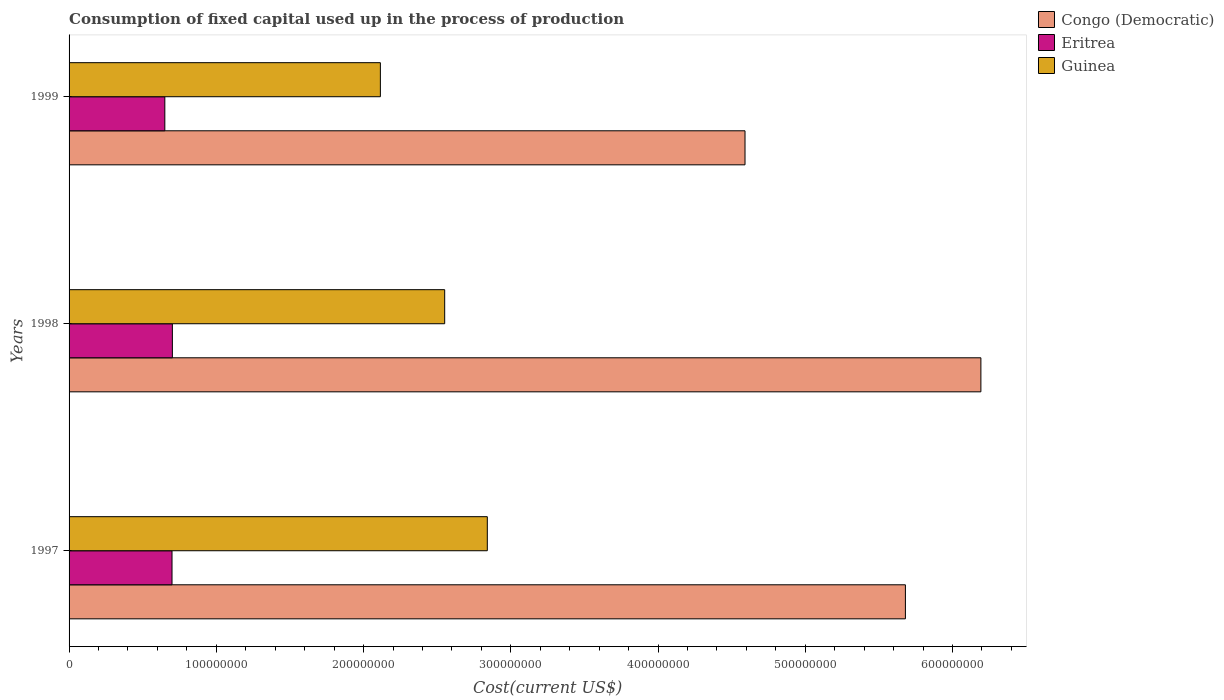How many different coloured bars are there?
Offer a terse response. 3. Are the number of bars on each tick of the Y-axis equal?
Give a very brief answer. Yes. How many bars are there on the 1st tick from the top?
Your answer should be compact. 3. What is the label of the 1st group of bars from the top?
Provide a short and direct response. 1999. In how many cases, is the number of bars for a given year not equal to the number of legend labels?
Your response must be concise. 0. What is the amount consumed in the process of production in Guinea in 1997?
Offer a terse response. 2.84e+08. Across all years, what is the maximum amount consumed in the process of production in Congo (Democratic)?
Offer a very short reply. 6.19e+08. Across all years, what is the minimum amount consumed in the process of production in Guinea?
Your answer should be compact. 2.11e+08. In which year was the amount consumed in the process of production in Guinea minimum?
Give a very brief answer. 1999. What is the total amount consumed in the process of production in Congo (Democratic) in the graph?
Ensure brevity in your answer.  1.65e+09. What is the difference between the amount consumed in the process of production in Guinea in 1998 and that in 1999?
Ensure brevity in your answer.  4.37e+07. What is the difference between the amount consumed in the process of production in Congo (Democratic) in 1997 and the amount consumed in the process of production in Guinea in 1998?
Keep it short and to the point. 3.13e+08. What is the average amount consumed in the process of production in Eritrea per year?
Make the answer very short. 6.84e+07. In the year 1999, what is the difference between the amount consumed in the process of production in Eritrea and amount consumed in the process of production in Guinea?
Offer a very short reply. -1.46e+08. In how many years, is the amount consumed in the process of production in Guinea greater than 360000000 US$?
Keep it short and to the point. 0. What is the ratio of the amount consumed in the process of production in Guinea in 1997 to that in 1998?
Your response must be concise. 1.11. Is the difference between the amount consumed in the process of production in Eritrea in 1997 and 1999 greater than the difference between the amount consumed in the process of production in Guinea in 1997 and 1999?
Keep it short and to the point. No. What is the difference between the highest and the second highest amount consumed in the process of production in Congo (Democratic)?
Offer a terse response. 5.13e+07. What is the difference between the highest and the lowest amount consumed in the process of production in Eritrea?
Your answer should be compact. 5.13e+06. In how many years, is the amount consumed in the process of production in Eritrea greater than the average amount consumed in the process of production in Eritrea taken over all years?
Give a very brief answer. 2. Is the sum of the amount consumed in the process of production in Eritrea in 1997 and 1999 greater than the maximum amount consumed in the process of production in Congo (Democratic) across all years?
Offer a very short reply. No. What does the 1st bar from the top in 1999 represents?
Provide a succinct answer. Guinea. What does the 1st bar from the bottom in 1999 represents?
Ensure brevity in your answer.  Congo (Democratic). Is it the case that in every year, the sum of the amount consumed in the process of production in Guinea and amount consumed in the process of production in Congo (Democratic) is greater than the amount consumed in the process of production in Eritrea?
Offer a terse response. Yes. Are all the bars in the graph horizontal?
Make the answer very short. Yes. How many years are there in the graph?
Your answer should be compact. 3. Does the graph contain grids?
Give a very brief answer. No. Where does the legend appear in the graph?
Ensure brevity in your answer.  Top right. How many legend labels are there?
Ensure brevity in your answer.  3. How are the legend labels stacked?
Make the answer very short. Vertical. What is the title of the graph?
Your answer should be compact. Consumption of fixed capital used up in the process of production. What is the label or title of the X-axis?
Give a very brief answer. Cost(current US$). What is the label or title of the Y-axis?
Provide a short and direct response. Years. What is the Cost(current US$) in Congo (Democratic) in 1997?
Provide a succinct answer. 5.68e+08. What is the Cost(current US$) in Eritrea in 1997?
Offer a very short reply. 6.99e+07. What is the Cost(current US$) of Guinea in 1997?
Provide a short and direct response. 2.84e+08. What is the Cost(current US$) of Congo (Democratic) in 1998?
Make the answer very short. 6.19e+08. What is the Cost(current US$) in Eritrea in 1998?
Offer a very short reply. 7.02e+07. What is the Cost(current US$) of Guinea in 1998?
Keep it short and to the point. 2.55e+08. What is the Cost(current US$) in Congo (Democratic) in 1999?
Your answer should be very brief. 4.59e+08. What is the Cost(current US$) of Eritrea in 1999?
Provide a short and direct response. 6.50e+07. What is the Cost(current US$) in Guinea in 1999?
Your answer should be very brief. 2.11e+08. Across all years, what is the maximum Cost(current US$) in Congo (Democratic)?
Your response must be concise. 6.19e+08. Across all years, what is the maximum Cost(current US$) of Eritrea?
Your answer should be very brief. 7.02e+07. Across all years, what is the maximum Cost(current US$) of Guinea?
Offer a very short reply. 2.84e+08. Across all years, what is the minimum Cost(current US$) in Congo (Democratic)?
Provide a succinct answer. 4.59e+08. Across all years, what is the minimum Cost(current US$) in Eritrea?
Give a very brief answer. 6.50e+07. Across all years, what is the minimum Cost(current US$) in Guinea?
Offer a terse response. 2.11e+08. What is the total Cost(current US$) in Congo (Democratic) in the graph?
Provide a succinct answer. 1.65e+09. What is the total Cost(current US$) in Eritrea in the graph?
Offer a very short reply. 2.05e+08. What is the total Cost(current US$) of Guinea in the graph?
Give a very brief answer. 7.51e+08. What is the difference between the Cost(current US$) of Congo (Democratic) in 1997 and that in 1998?
Keep it short and to the point. -5.13e+07. What is the difference between the Cost(current US$) of Eritrea in 1997 and that in 1998?
Ensure brevity in your answer.  -2.43e+05. What is the difference between the Cost(current US$) in Guinea in 1997 and that in 1998?
Keep it short and to the point. 2.89e+07. What is the difference between the Cost(current US$) in Congo (Democratic) in 1997 and that in 1999?
Give a very brief answer. 1.09e+08. What is the difference between the Cost(current US$) of Eritrea in 1997 and that in 1999?
Provide a short and direct response. 4.88e+06. What is the difference between the Cost(current US$) in Guinea in 1997 and that in 1999?
Your answer should be compact. 7.26e+07. What is the difference between the Cost(current US$) of Congo (Democratic) in 1998 and that in 1999?
Your answer should be very brief. 1.60e+08. What is the difference between the Cost(current US$) of Eritrea in 1998 and that in 1999?
Your answer should be very brief. 5.13e+06. What is the difference between the Cost(current US$) of Guinea in 1998 and that in 1999?
Offer a very short reply. 4.37e+07. What is the difference between the Cost(current US$) of Congo (Democratic) in 1997 and the Cost(current US$) of Eritrea in 1998?
Your response must be concise. 4.98e+08. What is the difference between the Cost(current US$) of Congo (Democratic) in 1997 and the Cost(current US$) of Guinea in 1998?
Provide a succinct answer. 3.13e+08. What is the difference between the Cost(current US$) of Eritrea in 1997 and the Cost(current US$) of Guinea in 1998?
Your response must be concise. -1.85e+08. What is the difference between the Cost(current US$) in Congo (Democratic) in 1997 and the Cost(current US$) in Eritrea in 1999?
Keep it short and to the point. 5.03e+08. What is the difference between the Cost(current US$) in Congo (Democratic) in 1997 and the Cost(current US$) in Guinea in 1999?
Make the answer very short. 3.57e+08. What is the difference between the Cost(current US$) in Eritrea in 1997 and the Cost(current US$) in Guinea in 1999?
Provide a short and direct response. -1.42e+08. What is the difference between the Cost(current US$) of Congo (Democratic) in 1998 and the Cost(current US$) of Eritrea in 1999?
Your answer should be compact. 5.54e+08. What is the difference between the Cost(current US$) of Congo (Democratic) in 1998 and the Cost(current US$) of Guinea in 1999?
Give a very brief answer. 4.08e+08. What is the difference between the Cost(current US$) in Eritrea in 1998 and the Cost(current US$) in Guinea in 1999?
Keep it short and to the point. -1.41e+08. What is the average Cost(current US$) of Congo (Democratic) per year?
Ensure brevity in your answer.  5.49e+08. What is the average Cost(current US$) in Eritrea per year?
Your answer should be compact. 6.84e+07. What is the average Cost(current US$) in Guinea per year?
Make the answer very short. 2.50e+08. In the year 1997, what is the difference between the Cost(current US$) of Congo (Democratic) and Cost(current US$) of Eritrea?
Make the answer very short. 4.98e+08. In the year 1997, what is the difference between the Cost(current US$) of Congo (Democratic) and Cost(current US$) of Guinea?
Your answer should be compact. 2.84e+08. In the year 1997, what is the difference between the Cost(current US$) in Eritrea and Cost(current US$) in Guinea?
Your answer should be very brief. -2.14e+08. In the year 1998, what is the difference between the Cost(current US$) of Congo (Democratic) and Cost(current US$) of Eritrea?
Make the answer very short. 5.49e+08. In the year 1998, what is the difference between the Cost(current US$) of Congo (Democratic) and Cost(current US$) of Guinea?
Provide a succinct answer. 3.64e+08. In the year 1998, what is the difference between the Cost(current US$) of Eritrea and Cost(current US$) of Guinea?
Your answer should be very brief. -1.85e+08. In the year 1999, what is the difference between the Cost(current US$) of Congo (Democratic) and Cost(current US$) of Eritrea?
Your answer should be very brief. 3.94e+08. In the year 1999, what is the difference between the Cost(current US$) of Congo (Democratic) and Cost(current US$) of Guinea?
Your answer should be very brief. 2.48e+08. In the year 1999, what is the difference between the Cost(current US$) in Eritrea and Cost(current US$) in Guinea?
Provide a short and direct response. -1.46e+08. What is the ratio of the Cost(current US$) of Congo (Democratic) in 1997 to that in 1998?
Provide a succinct answer. 0.92. What is the ratio of the Cost(current US$) in Eritrea in 1997 to that in 1998?
Provide a short and direct response. 1. What is the ratio of the Cost(current US$) in Guinea in 1997 to that in 1998?
Make the answer very short. 1.11. What is the ratio of the Cost(current US$) in Congo (Democratic) in 1997 to that in 1999?
Provide a short and direct response. 1.24. What is the ratio of the Cost(current US$) in Eritrea in 1997 to that in 1999?
Offer a terse response. 1.08. What is the ratio of the Cost(current US$) in Guinea in 1997 to that in 1999?
Provide a succinct answer. 1.34. What is the ratio of the Cost(current US$) of Congo (Democratic) in 1998 to that in 1999?
Ensure brevity in your answer.  1.35. What is the ratio of the Cost(current US$) in Eritrea in 1998 to that in 1999?
Your answer should be compact. 1.08. What is the ratio of the Cost(current US$) in Guinea in 1998 to that in 1999?
Provide a succinct answer. 1.21. What is the difference between the highest and the second highest Cost(current US$) in Congo (Democratic)?
Make the answer very short. 5.13e+07. What is the difference between the highest and the second highest Cost(current US$) of Eritrea?
Keep it short and to the point. 2.43e+05. What is the difference between the highest and the second highest Cost(current US$) of Guinea?
Your response must be concise. 2.89e+07. What is the difference between the highest and the lowest Cost(current US$) of Congo (Democratic)?
Keep it short and to the point. 1.60e+08. What is the difference between the highest and the lowest Cost(current US$) in Eritrea?
Your response must be concise. 5.13e+06. What is the difference between the highest and the lowest Cost(current US$) in Guinea?
Make the answer very short. 7.26e+07. 